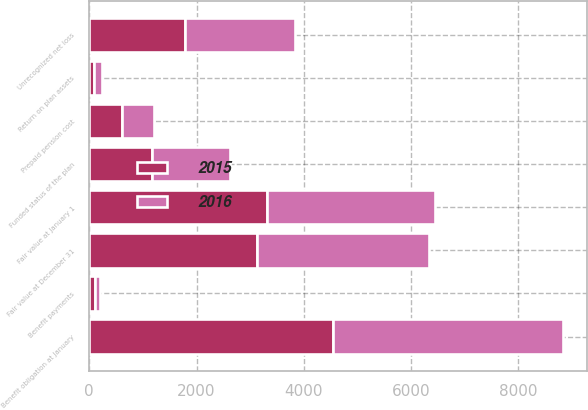Convert chart. <chart><loc_0><loc_0><loc_500><loc_500><stacked_bar_chart><ecel><fcel>Benefit obligation at January<fcel>Fair value at January 1<fcel>Return on plan assets<fcel>Benefit payments<fcel>Fair value at December 31<fcel>Funded status of the plan<fcel>Unrecognized net loss<fcel>Prepaid pension cost<nl><fcel>2016<fcel>4304<fcel>3130<fcel>160<fcel>98<fcel>3195<fcel>1449<fcel>2054<fcel>605<nl><fcel>2015<fcel>4536<fcel>3317<fcel>84<fcel>106<fcel>3130<fcel>1174<fcel>1777<fcel>603<nl></chart> 